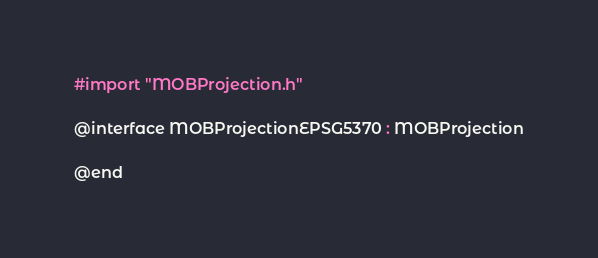<code> <loc_0><loc_0><loc_500><loc_500><_C_>#import "MOBProjection.h"

@interface MOBProjectionEPSG5370 : MOBProjection

@end
</code> 